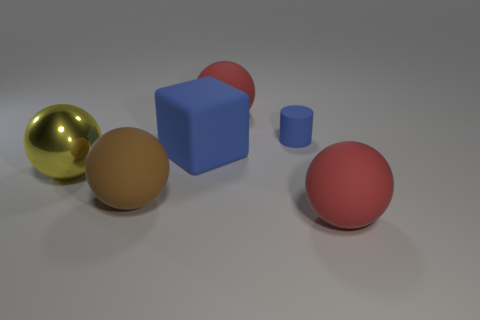Subtract all brown spheres. How many spheres are left? 3 Subtract all blocks. How many objects are left? 5 Subtract 3 spheres. How many spheres are left? 1 Add 4 rubber blocks. How many rubber blocks are left? 5 Add 2 tiny purple objects. How many tiny purple objects exist? 2 Add 2 blue rubber things. How many objects exist? 8 Subtract all red balls. How many balls are left? 2 Subtract 2 red balls. How many objects are left? 4 Subtract all gray spheres. Subtract all cyan cylinders. How many spheres are left? 4 Subtract all green cylinders. How many green balls are left? 0 